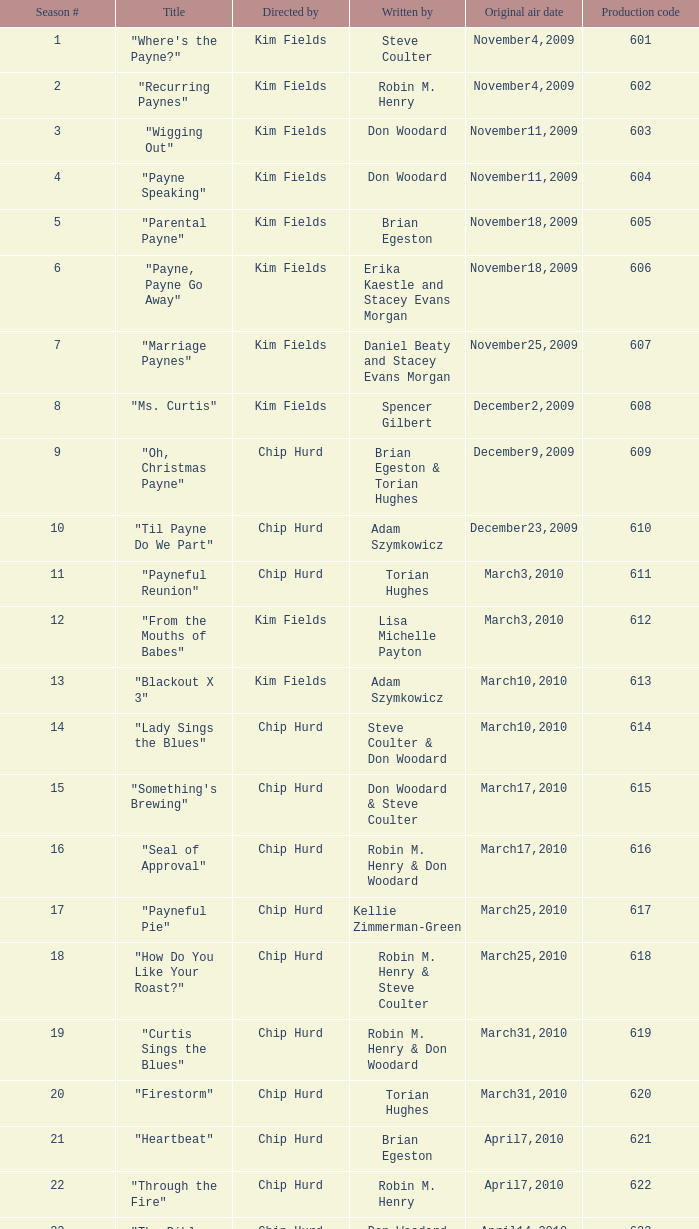What is the heading of the episode with the production number 624? "Matured Investment". 